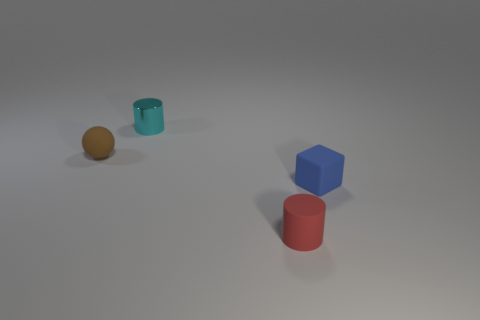What shape is the object on the right side of the small cylinder that is in front of the tiny rubber object left of the tiny metal thing?
Provide a succinct answer. Cube. There is a rubber object that is both behind the red cylinder and on the right side of the tiny brown matte thing; what shape is it?
Your answer should be very brief. Cube. Is there a blue cube of the same size as the red cylinder?
Your answer should be compact. Yes. Is the shape of the small matte object that is behind the tiny blue object the same as  the tiny red thing?
Your answer should be very brief. No. Do the small cyan metal object and the small brown matte object have the same shape?
Offer a terse response. No. Are there any large brown matte objects that have the same shape as the tiny brown rubber thing?
Your answer should be compact. No. What is the shape of the tiny object that is behind the matte object that is behind the small blue cube?
Give a very brief answer. Cylinder. What color is the tiny thing that is in front of the blue matte cube?
Offer a very short reply. Red. The other thing that is the same shape as the red rubber thing is what size?
Make the answer very short. Small. Are there any purple metal cylinders?
Keep it short and to the point. No. 